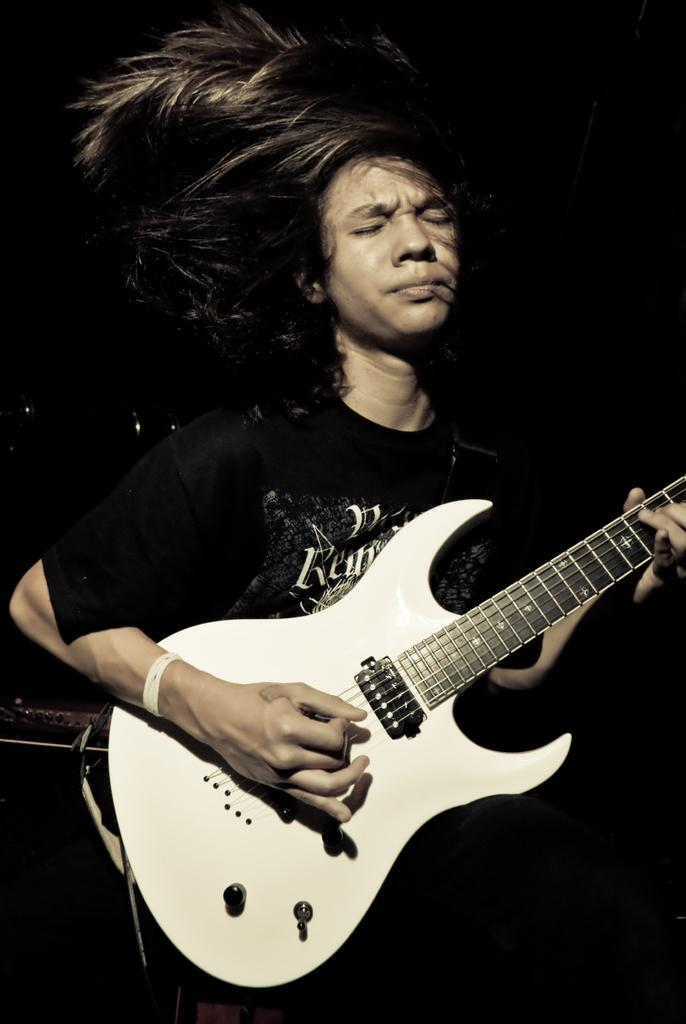What is the main subject of the image? There is a person in the image. What is the person holding in the image? The person is holding a guitar. What type of steam is coming out of the guitar in the image? There is no steam coming out of the guitar in the image, as it is not a source of steam. 